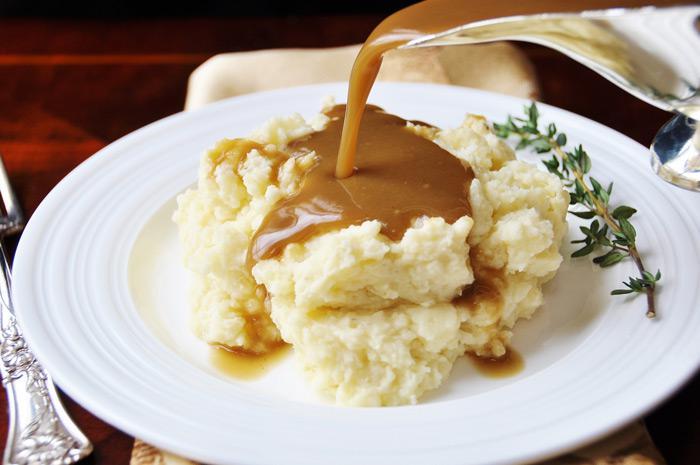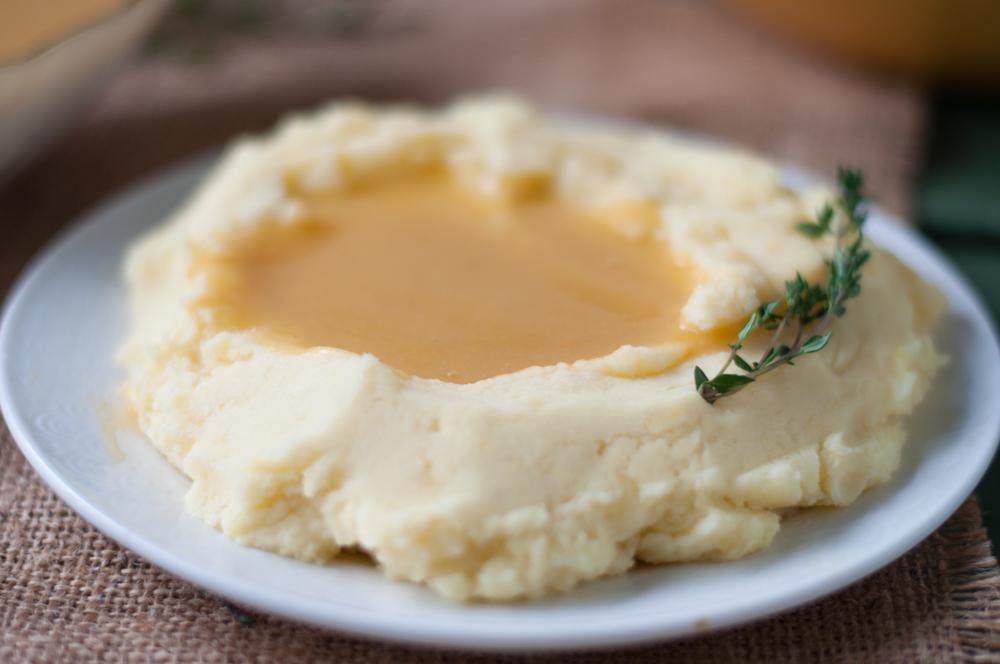The first image is the image on the left, the second image is the image on the right. Analyze the images presented: Is the assertion "An eating utensil can be seen in the image on the left." valid? Answer yes or no. Yes. 